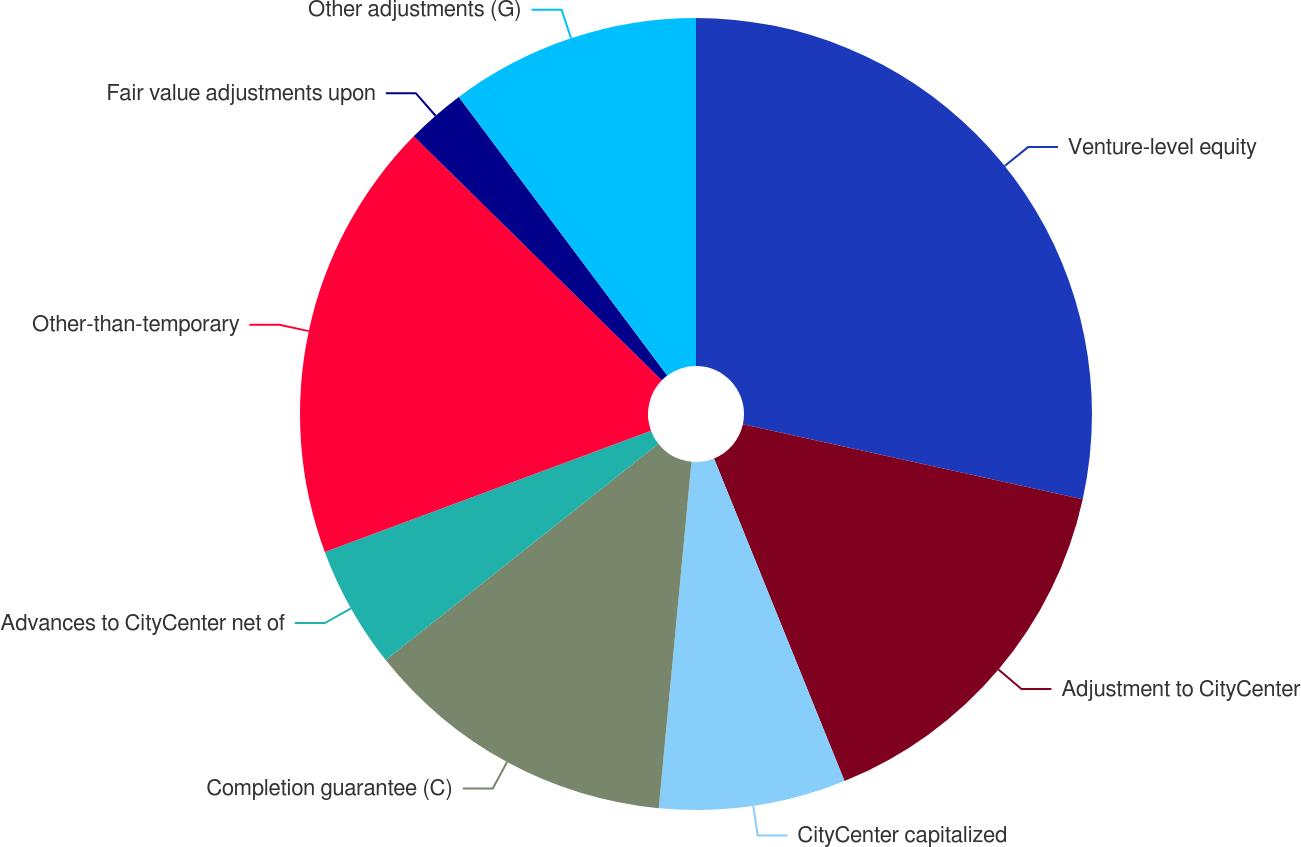Convert chart. <chart><loc_0><loc_0><loc_500><loc_500><pie_chart><fcel>Venture-level equity<fcel>Adjustment to CityCenter<fcel>CityCenter capitalized<fcel>Completion guarantee (C)<fcel>Advances to CityCenter net of<fcel>Other-than-temporary<fcel>Fair value adjustments upon<fcel>Other adjustments (G)<nl><fcel>28.45%<fcel>15.43%<fcel>7.62%<fcel>12.83%<fcel>5.01%<fcel>18.03%<fcel>2.41%<fcel>10.22%<nl></chart> 